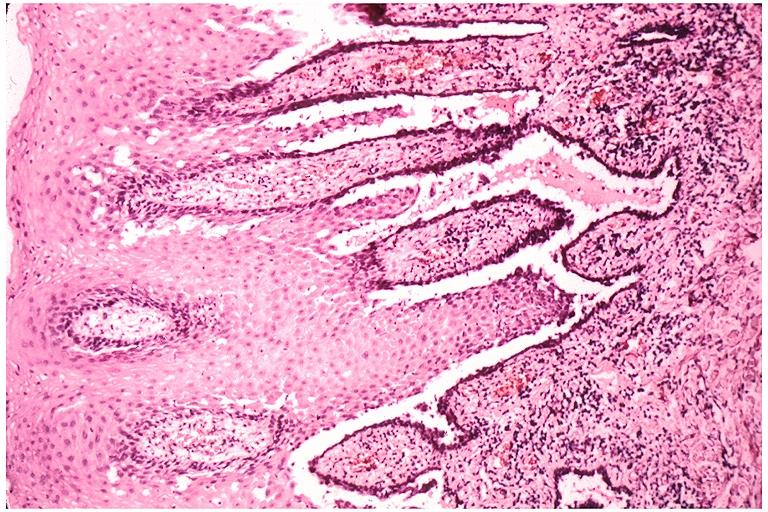does opened base of skull with brain show pemphigus vulgaris?
Answer the question using a single word or phrase. No 